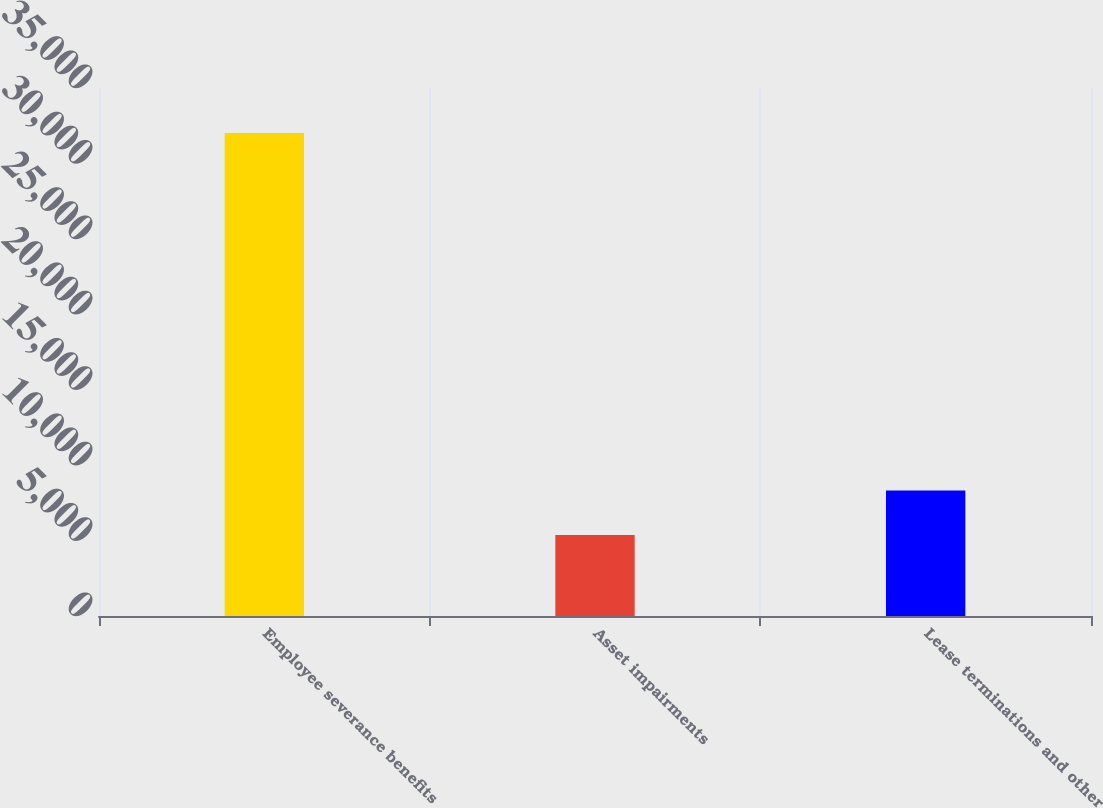<chart> <loc_0><loc_0><loc_500><loc_500><bar_chart><fcel>Employee severance benefits<fcel>Asset impairments<fcel>Lease terminations and other<nl><fcel>32023<fcel>5362<fcel>8320<nl></chart> 